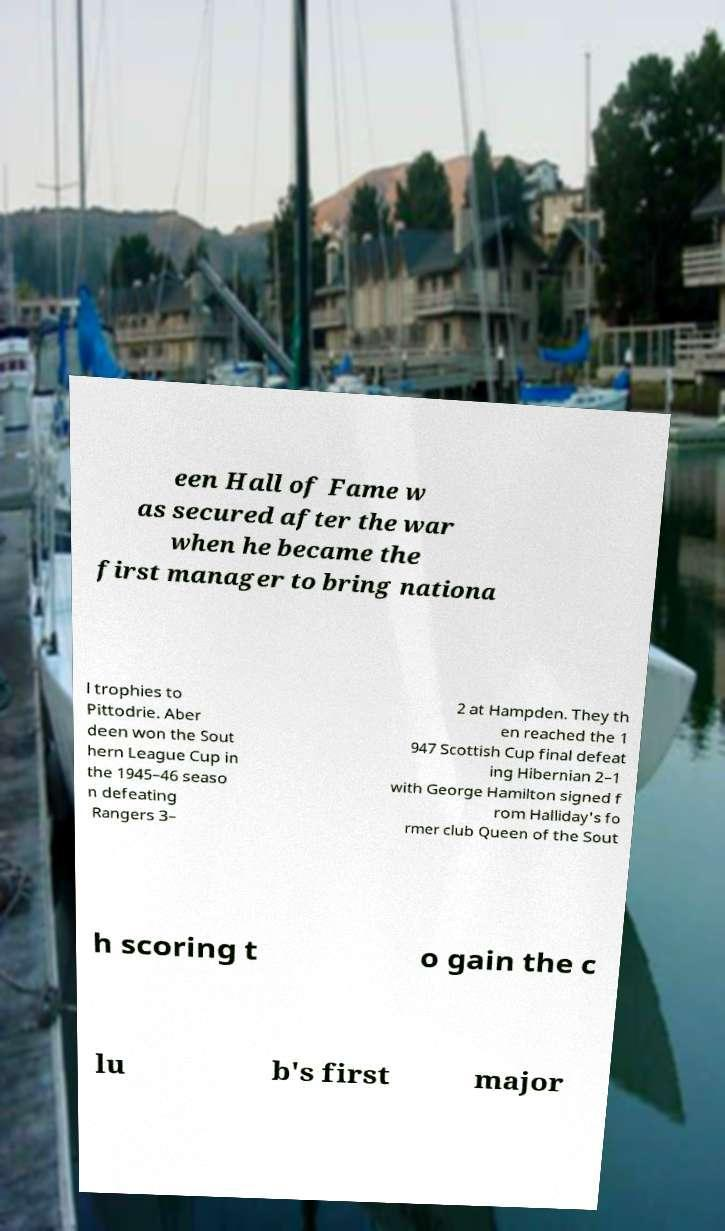There's text embedded in this image that I need extracted. Can you transcribe it verbatim? een Hall of Fame w as secured after the war when he became the first manager to bring nationa l trophies to Pittodrie. Aber deen won the Sout hern League Cup in the 1945–46 seaso n defeating Rangers 3– 2 at Hampden. They th en reached the 1 947 Scottish Cup final defeat ing Hibernian 2–1 with George Hamilton signed f rom Halliday's fo rmer club Queen of the Sout h scoring t o gain the c lu b's first major 